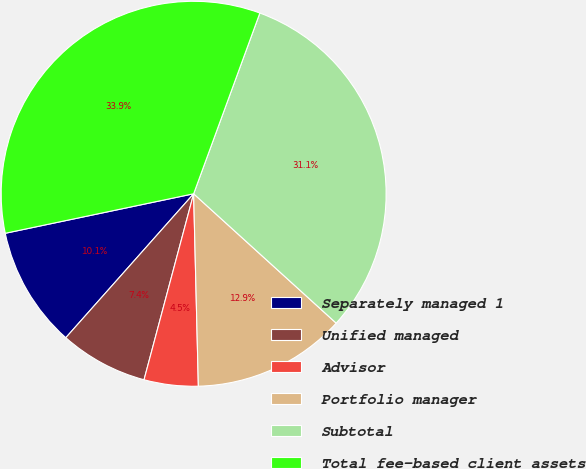Convert chart. <chart><loc_0><loc_0><loc_500><loc_500><pie_chart><fcel>Separately managed 1<fcel>Unified managed<fcel>Advisor<fcel>Portfolio manager<fcel>Subtotal<fcel>Total fee-based client assets<nl><fcel>10.15%<fcel>7.41%<fcel>4.54%<fcel>12.88%<fcel>31.14%<fcel>33.88%<nl></chart> 